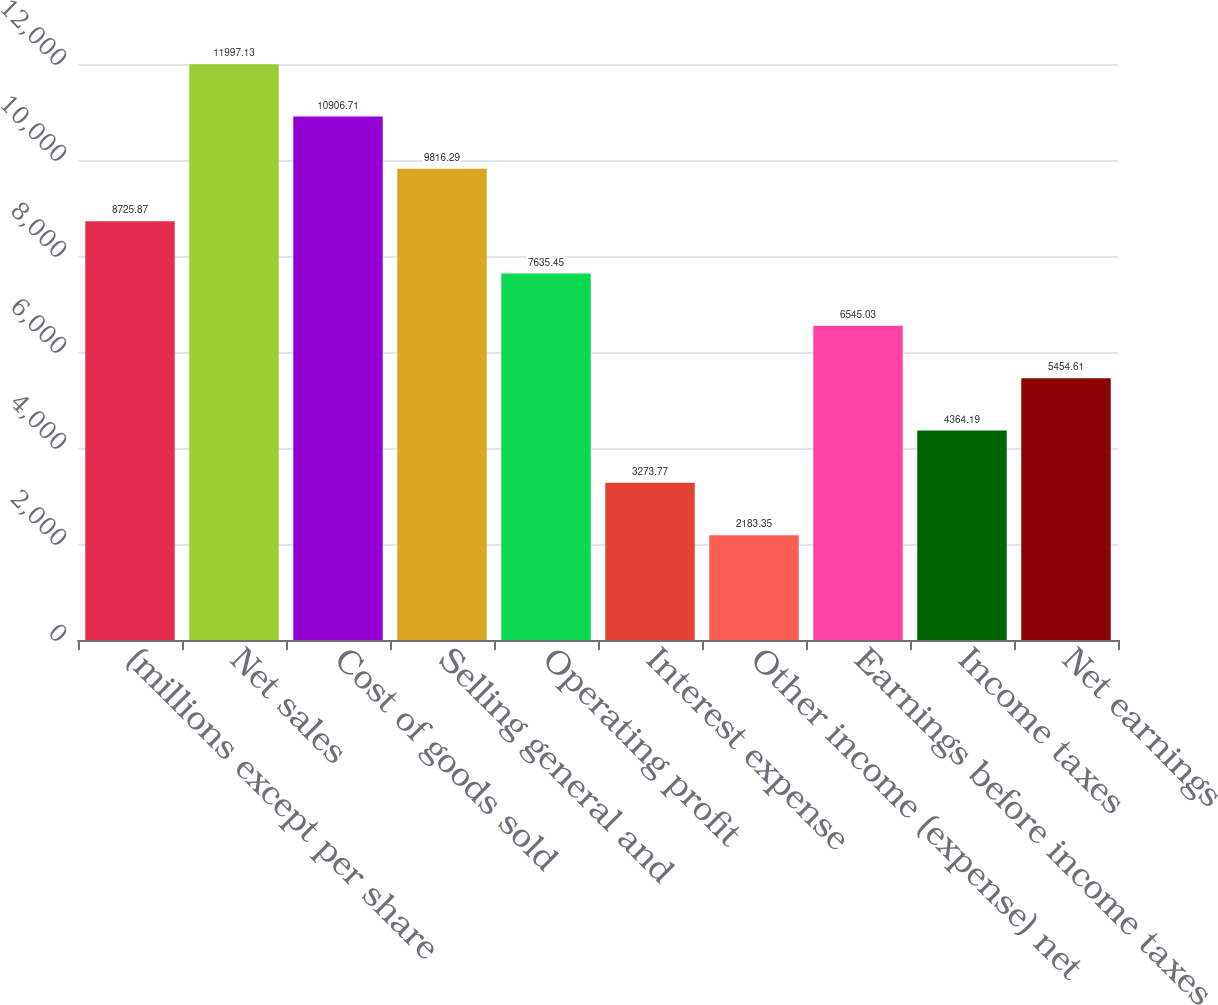Convert chart to OTSL. <chart><loc_0><loc_0><loc_500><loc_500><bar_chart><fcel>(millions except per share<fcel>Net sales<fcel>Cost of goods sold<fcel>Selling general and<fcel>Operating profit<fcel>Interest expense<fcel>Other income (expense) net<fcel>Earnings before income taxes<fcel>Income taxes<fcel>Net earnings<nl><fcel>8725.87<fcel>11997.1<fcel>10906.7<fcel>9816.29<fcel>7635.45<fcel>3273.77<fcel>2183.35<fcel>6545.03<fcel>4364.19<fcel>5454.61<nl></chart> 